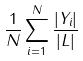Convert formula to latex. <formula><loc_0><loc_0><loc_500><loc_500>\frac { 1 } { N } \sum _ { i = 1 } ^ { N } \frac { | Y _ { i } | } { | L | }</formula> 